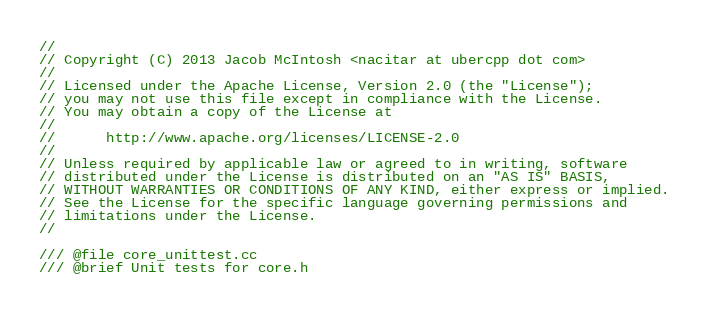<code> <loc_0><loc_0><loc_500><loc_500><_C++_>//
// Copyright (C) 2013 Jacob McIntosh <nacitar at ubercpp dot com>
//
// Licensed under the Apache License, Version 2.0 (the "License");
// you may not use this file except in compliance with the License.
// You may obtain a copy of the License at
//
//      http://www.apache.org/licenses/LICENSE-2.0
//
// Unless required by applicable law or agreed to in writing, software
// distributed under the License is distributed on an "AS IS" BASIS,
// WITHOUT WARRANTIES OR CONDITIONS OF ANY KIND, either express or implied.
// See the License for the specific language governing permissions and
// limitations under the License.
//

/// @file core_unittest.cc
/// @brief Unit tests for core.h</code> 